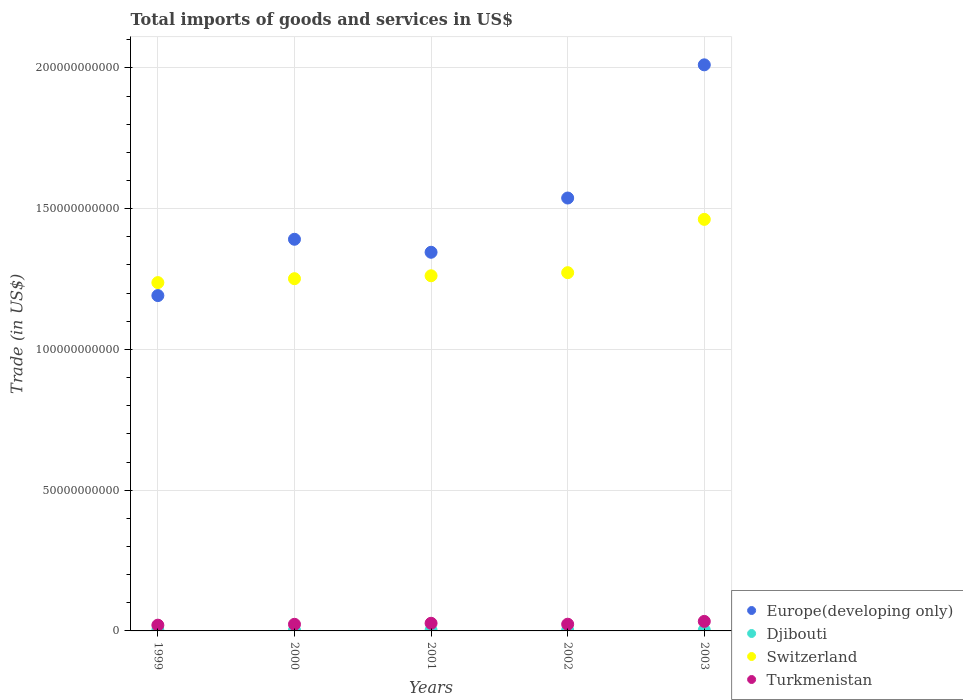How many different coloured dotlines are there?
Keep it short and to the point. 4. Is the number of dotlines equal to the number of legend labels?
Your response must be concise. Yes. What is the total imports of goods and services in Europe(developing only) in 2003?
Ensure brevity in your answer.  2.01e+11. Across all years, what is the maximum total imports of goods and services in Europe(developing only)?
Keep it short and to the point. 2.01e+11. Across all years, what is the minimum total imports of goods and services in Djibouti?
Your answer should be very brief. 2.59e+08. In which year was the total imports of goods and services in Switzerland maximum?
Ensure brevity in your answer.  2003. What is the total total imports of goods and services in Switzerland in the graph?
Your answer should be very brief. 6.48e+11. What is the difference between the total imports of goods and services in Europe(developing only) in 2000 and that in 2001?
Make the answer very short. 4.62e+09. What is the difference between the total imports of goods and services in Djibouti in 2001 and the total imports of goods and services in Switzerland in 2000?
Provide a short and direct response. -1.25e+11. What is the average total imports of goods and services in Turkmenistan per year?
Offer a terse response. 2.58e+09. In the year 2001, what is the difference between the total imports of goods and services in Djibouti and total imports of goods and services in Switzerland?
Your response must be concise. -1.26e+11. What is the ratio of the total imports of goods and services in Switzerland in 2002 to that in 2003?
Your answer should be compact. 0.87. Is the difference between the total imports of goods and services in Djibouti in 1999 and 2002 greater than the difference between the total imports of goods and services in Switzerland in 1999 and 2002?
Give a very brief answer. Yes. What is the difference between the highest and the second highest total imports of goods and services in Djibouti?
Provide a succinct answer. 2.75e+07. What is the difference between the highest and the lowest total imports of goods and services in Switzerland?
Your response must be concise. 2.25e+1. Is the sum of the total imports of goods and services in Turkmenistan in 1999 and 2003 greater than the maximum total imports of goods and services in Europe(developing only) across all years?
Your answer should be compact. No. Is it the case that in every year, the sum of the total imports of goods and services in Djibouti and total imports of goods and services in Europe(developing only)  is greater than the total imports of goods and services in Switzerland?
Ensure brevity in your answer.  No. Does the total imports of goods and services in Europe(developing only) monotonically increase over the years?
Offer a very short reply. No. Is the total imports of goods and services in Europe(developing only) strictly less than the total imports of goods and services in Turkmenistan over the years?
Your answer should be compact. No. How are the legend labels stacked?
Provide a succinct answer. Vertical. What is the title of the graph?
Offer a very short reply. Total imports of goods and services in US$. Does "Monaco" appear as one of the legend labels in the graph?
Offer a terse response. No. What is the label or title of the Y-axis?
Your answer should be very brief. Trade (in US$). What is the Trade (in US$) of Europe(developing only) in 1999?
Keep it short and to the point. 1.19e+11. What is the Trade (in US$) of Djibouti in 1999?
Provide a short and direct response. 2.59e+08. What is the Trade (in US$) of Switzerland in 1999?
Offer a very short reply. 1.24e+11. What is the Trade (in US$) in Turkmenistan in 1999?
Your response must be concise. 2.05e+09. What is the Trade (in US$) in Europe(developing only) in 2000?
Offer a very short reply. 1.39e+11. What is the Trade (in US$) in Djibouti in 2000?
Make the answer very short. 2.78e+08. What is the Trade (in US$) in Switzerland in 2000?
Offer a very short reply. 1.25e+11. What is the Trade (in US$) of Turkmenistan in 2000?
Give a very brief answer. 2.35e+09. What is the Trade (in US$) in Europe(developing only) in 2001?
Your response must be concise. 1.35e+11. What is the Trade (in US$) of Djibouti in 2001?
Offer a terse response. 2.62e+08. What is the Trade (in US$) of Switzerland in 2001?
Your answer should be compact. 1.26e+11. What is the Trade (in US$) in Turkmenistan in 2001?
Give a very brief answer. 2.72e+09. What is the Trade (in US$) of Europe(developing only) in 2002?
Make the answer very short. 1.54e+11. What is the Trade (in US$) of Djibouti in 2002?
Keep it short and to the point. 2.59e+08. What is the Trade (in US$) in Switzerland in 2002?
Your answer should be very brief. 1.27e+11. What is the Trade (in US$) in Turkmenistan in 2002?
Your answer should be compact. 2.38e+09. What is the Trade (in US$) of Europe(developing only) in 2003?
Offer a terse response. 2.01e+11. What is the Trade (in US$) in Djibouti in 2003?
Offer a very short reply. 3.05e+08. What is the Trade (in US$) in Switzerland in 2003?
Your response must be concise. 1.46e+11. What is the Trade (in US$) of Turkmenistan in 2003?
Provide a succinct answer. 3.38e+09. Across all years, what is the maximum Trade (in US$) in Europe(developing only)?
Make the answer very short. 2.01e+11. Across all years, what is the maximum Trade (in US$) in Djibouti?
Keep it short and to the point. 3.05e+08. Across all years, what is the maximum Trade (in US$) in Switzerland?
Provide a short and direct response. 1.46e+11. Across all years, what is the maximum Trade (in US$) of Turkmenistan?
Your answer should be compact. 3.38e+09. Across all years, what is the minimum Trade (in US$) in Europe(developing only)?
Ensure brevity in your answer.  1.19e+11. Across all years, what is the minimum Trade (in US$) of Djibouti?
Ensure brevity in your answer.  2.59e+08. Across all years, what is the minimum Trade (in US$) in Switzerland?
Ensure brevity in your answer.  1.24e+11. Across all years, what is the minimum Trade (in US$) of Turkmenistan?
Keep it short and to the point. 2.05e+09. What is the total Trade (in US$) of Europe(developing only) in the graph?
Offer a terse response. 7.48e+11. What is the total Trade (in US$) of Djibouti in the graph?
Your answer should be compact. 1.36e+09. What is the total Trade (in US$) of Switzerland in the graph?
Provide a succinct answer. 6.48e+11. What is the total Trade (in US$) in Turkmenistan in the graph?
Your answer should be very brief. 1.29e+1. What is the difference between the Trade (in US$) of Europe(developing only) in 1999 and that in 2000?
Offer a terse response. -2.00e+1. What is the difference between the Trade (in US$) of Djibouti in 1999 and that in 2000?
Make the answer very short. -1.85e+07. What is the difference between the Trade (in US$) in Switzerland in 1999 and that in 2000?
Provide a succinct answer. -1.39e+09. What is the difference between the Trade (in US$) of Turkmenistan in 1999 and that in 2000?
Your response must be concise. -3.05e+08. What is the difference between the Trade (in US$) in Europe(developing only) in 1999 and that in 2001?
Your answer should be very brief. -1.54e+1. What is the difference between the Trade (in US$) of Djibouti in 1999 and that in 2001?
Offer a very short reply. -2.78e+06. What is the difference between the Trade (in US$) of Switzerland in 1999 and that in 2001?
Provide a short and direct response. -2.43e+09. What is the difference between the Trade (in US$) in Turkmenistan in 1999 and that in 2001?
Your response must be concise. -6.71e+08. What is the difference between the Trade (in US$) of Europe(developing only) in 1999 and that in 2002?
Ensure brevity in your answer.  -3.47e+1. What is the difference between the Trade (in US$) of Djibouti in 1999 and that in 2002?
Provide a succinct answer. 6.13e+05. What is the difference between the Trade (in US$) of Switzerland in 1999 and that in 2002?
Offer a very short reply. -3.53e+09. What is the difference between the Trade (in US$) in Turkmenistan in 1999 and that in 2002?
Make the answer very short. -3.37e+08. What is the difference between the Trade (in US$) in Europe(developing only) in 1999 and that in 2003?
Provide a short and direct response. -8.20e+1. What is the difference between the Trade (in US$) in Djibouti in 1999 and that in 2003?
Provide a short and direct response. -4.60e+07. What is the difference between the Trade (in US$) of Switzerland in 1999 and that in 2003?
Offer a very short reply. -2.25e+1. What is the difference between the Trade (in US$) in Turkmenistan in 1999 and that in 2003?
Give a very brief answer. -1.34e+09. What is the difference between the Trade (in US$) in Europe(developing only) in 2000 and that in 2001?
Provide a succinct answer. 4.62e+09. What is the difference between the Trade (in US$) of Djibouti in 2000 and that in 2001?
Provide a short and direct response. 1.57e+07. What is the difference between the Trade (in US$) of Switzerland in 2000 and that in 2001?
Ensure brevity in your answer.  -1.04e+09. What is the difference between the Trade (in US$) in Turkmenistan in 2000 and that in 2001?
Provide a succinct answer. -3.66e+08. What is the difference between the Trade (in US$) in Europe(developing only) in 2000 and that in 2002?
Keep it short and to the point. -1.47e+1. What is the difference between the Trade (in US$) in Djibouti in 2000 and that in 2002?
Your response must be concise. 1.91e+07. What is the difference between the Trade (in US$) of Switzerland in 2000 and that in 2002?
Keep it short and to the point. -2.14e+09. What is the difference between the Trade (in US$) in Turkmenistan in 2000 and that in 2002?
Make the answer very short. -3.20e+07. What is the difference between the Trade (in US$) of Europe(developing only) in 2000 and that in 2003?
Make the answer very short. -6.20e+1. What is the difference between the Trade (in US$) in Djibouti in 2000 and that in 2003?
Offer a very short reply. -2.75e+07. What is the difference between the Trade (in US$) in Switzerland in 2000 and that in 2003?
Give a very brief answer. -2.11e+1. What is the difference between the Trade (in US$) in Turkmenistan in 2000 and that in 2003?
Give a very brief answer. -1.03e+09. What is the difference between the Trade (in US$) of Europe(developing only) in 2001 and that in 2002?
Give a very brief answer. -1.93e+1. What is the difference between the Trade (in US$) of Djibouti in 2001 and that in 2002?
Give a very brief answer. 3.39e+06. What is the difference between the Trade (in US$) in Switzerland in 2001 and that in 2002?
Make the answer very short. -1.10e+09. What is the difference between the Trade (in US$) of Turkmenistan in 2001 and that in 2002?
Provide a succinct answer. 3.34e+08. What is the difference between the Trade (in US$) in Europe(developing only) in 2001 and that in 2003?
Your answer should be very brief. -6.66e+1. What is the difference between the Trade (in US$) of Djibouti in 2001 and that in 2003?
Your answer should be very brief. -4.32e+07. What is the difference between the Trade (in US$) in Switzerland in 2001 and that in 2003?
Your answer should be very brief. -2.00e+1. What is the difference between the Trade (in US$) in Turkmenistan in 2001 and that in 2003?
Offer a very short reply. -6.67e+08. What is the difference between the Trade (in US$) of Europe(developing only) in 2002 and that in 2003?
Provide a short and direct response. -4.73e+1. What is the difference between the Trade (in US$) in Djibouti in 2002 and that in 2003?
Give a very brief answer. -4.66e+07. What is the difference between the Trade (in US$) in Switzerland in 2002 and that in 2003?
Make the answer very short. -1.89e+1. What is the difference between the Trade (in US$) of Turkmenistan in 2002 and that in 2003?
Your response must be concise. -1.00e+09. What is the difference between the Trade (in US$) in Europe(developing only) in 1999 and the Trade (in US$) in Djibouti in 2000?
Your response must be concise. 1.19e+11. What is the difference between the Trade (in US$) of Europe(developing only) in 1999 and the Trade (in US$) of Switzerland in 2000?
Offer a terse response. -6.00e+09. What is the difference between the Trade (in US$) in Europe(developing only) in 1999 and the Trade (in US$) in Turkmenistan in 2000?
Offer a terse response. 1.17e+11. What is the difference between the Trade (in US$) in Djibouti in 1999 and the Trade (in US$) in Switzerland in 2000?
Ensure brevity in your answer.  -1.25e+11. What is the difference between the Trade (in US$) in Djibouti in 1999 and the Trade (in US$) in Turkmenistan in 2000?
Provide a succinct answer. -2.09e+09. What is the difference between the Trade (in US$) in Switzerland in 1999 and the Trade (in US$) in Turkmenistan in 2000?
Keep it short and to the point. 1.21e+11. What is the difference between the Trade (in US$) of Europe(developing only) in 1999 and the Trade (in US$) of Djibouti in 2001?
Make the answer very short. 1.19e+11. What is the difference between the Trade (in US$) of Europe(developing only) in 1999 and the Trade (in US$) of Switzerland in 2001?
Offer a very short reply. -7.04e+09. What is the difference between the Trade (in US$) in Europe(developing only) in 1999 and the Trade (in US$) in Turkmenistan in 2001?
Provide a succinct answer. 1.16e+11. What is the difference between the Trade (in US$) in Djibouti in 1999 and the Trade (in US$) in Switzerland in 2001?
Keep it short and to the point. -1.26e+11. What is the difference between the Trade (in US$) of Djibouti in 1999 and the Trade (in US$) of Turkmenistan in 2001?
Your answer should be compact. -2.46e+09. What is the difference between the Trade (in US$) of Switzerland in 1999 and the Trade (in US$) of Turkmenistan in 2001?
Ensure brevity in your answer.  1.21e+11. What is the difference between the Trade (in US$) of Europe(developing only) in 1999 and the Trade (in US$) of Djibouti in 2002?
Ensure brevity in your answer.  1.19e+11. What is the difference between the Trade (in US$) of Europe(developing only) in 1999 and the Trade (in US$) of Switzerland in 2002?
Give a very brief answer. -8.14e+09. What is the difference between the Trade (in US$) of Europe(developing only) in 1999 and the Trade (in US$) of Turkmenistan in 2002?
Offer a terse response. 1.17e+11. What is the difference between the Trade (in US$) in Djibouti in 1999 and the Trade (in US$) in Switzerland in 2002?
Ensure brevity in your answer.  -1.27e+11. What is the difference between the Trade (in US$) of Djibouti in 1999 and the Trade (in US$) of Turkmenistan in 2002?
Your answer should be very brief. -2.12e+09. What is the difference between the Trade (in US$) in Switzerland in 1999 and the Trade (in US$) in Turkmenistan in 2002?
Give a very brief answer. 1.21e+11. What is the difference between the Trade (in US$) of Europe(developing only) in 1999 and the Trade (in US$) of Djibouti in 2003?
Your response must be concise. 1.19e+11. What is the difference between the Trade (in US$) in Europe(developing only) in 1999 and the Trade (in US$) in Switzerland in 2003?
Offer a terse response. -2.71e+1. What is the difference between the Trade (in US$) in Europe(developing only) in 1999 and the Trade (in US$) in Turkmenistan in 2003?
Your answer should be very brief. 1.16e+11. What is the difference between the Trade (in US$) in Djibouti in 1999 and the Trade (in US$) in Switzerland in 2003?
Offer a very short reply. -1.46e+11. What is the difference between the Trade (in US$) in Djibouti in 1999 and the Trade (in US$) in Turkmenistan in 2003?
Offer a terse response. -3.12e+09. What is the difference between the Trade (in US$) of Switzerland in 1999 and the Trade (in US$) of Turkmenistan in 2003?
Offer a very short reply. 1.20e+11. What is the difference between the Trade (in US$) of Europe(developing only) in 2000 and the Trade (in US$) of Djibouti in 2001?
Make the answer very short. 1.39e+11. What is the difference between the Trade (in US$) in Europe(developing only) in 2000 and the Trade (in US$) in Switzerland in 2001?
Your answer should be compact. 1.30e+1. What is the difference between the Trade (in US$) in Europe(developing only) in 2000 and the Trade (in US$) in Turkmenistan in 2001?
Your answer should be compact. 1.36e+11. What is the difference between the Trade (in US$) of Djibouti in 2000 and the Trade (in US$) of Switzerland in 2001?
Your response must be concise. -1.26e+11. What is the difference between the Trade (in US$) of Djibouti in 2000 and the Trade (in US$) of Turkmenistan in 2001?
Provide a short and direct response. -2.44e+09. What is the difference between the Trade (in US$) in Switzerland in 2000 and the Trade (in US$) in Turkmenistan in 2001?
Make the answer very short. 1.22e+11. What is the difference between the Trade (in US$) in Europe(developing only) in 2000 and the Trade (in US$) in Djibouti in 2002?
Your response must be concise. 1.39e+11. What is the difference between the Trade (in US$) in Europe(developing only) in 2000 and the Trade (in US$) in Switzerland in 2002?
Your response must be concise. 1.19e+1. What is the difference between the Trade (in US$) of Europe(developing only) in 2000 and the Trade (in US$) of Turkmenistan in 2002?
Provide a succinct answer. 1.37e+11. What is the difference between the Trade (in US$) of Djibouti in 2000 and the Trade (in US$) of Switzerland in 2002?
Your answer should be very brief. -1.27e+11. What is the difference between the Trade (in US$) in Djibouti in 2000 and the Trade (in US$) in Turkmenistan in 2002?
Your answer should be compact. -2.11e+09. What is the difference between the Trade (in US$) in Switzerland in 2000 and the Trade (in US$) in Turkmenistan in 2002?
Keep it short and to the point. 1.23e+11. What is the difference between the Trade (in US$) in Europe(developing only) in 2000 and the Trade (in US$) in Djibouti in 2003?
Your answer should be compact. 1.39e+11. What is the difference between the Trade (in US$) of Europe(developing only) in 2000 and the Trade (in US$) of Switzerland in 2003?
Offer a very short reply. -7.07e+09. What is the difference between the Trade (in US$) of Europe(developing only) in 2000 and the Trade (in US$) of Turkmenistan in 2003?
Give a very brief answer. 1.36e+11. What is the difference between the Trade (in US$) in Djibouti in 2000 and the Trade (in US$) in Switzerland in 2003?
Offer a terse response. -1.46e+11. What is the difference between the Trade (in US$) in Djibouti in 2000 and the Trade (in US$) in Turkmenistan in 2003?
Your answer should be compact. -3.11e+09. What is the difference between the Trade (in US$) in Switzerland in 2000 and the Trade (in US$) in Turkmenistan in 2003?
Your answer should be compact. 1.22e+11. What is the difference between the Trade (in US$) of Europe(developing only) in 2001 and the Trade (in US$) of Djibouti in 2002?
Provide a succinct answer. 1.34e+11. What is the difference between the Trade (in US$) of Europe(developing only) in 2001 and the Trade (in US$) of Switzerland in 2002?
Give a very brief answer. 7.25e+09. What is the difference between the Trade (in US$) in Europe(developing only) in 2001 and the Trade (in US$) in Turkmenistan in 2002?
Your response must be concise. 1.32e+11. What is the difference between the Trade (in US$) in Djibouti in 2001 and the Trade (in US$) in Switzerland in 2002?
Ensure brevity in your answer.  -1.27e+11. What is the difference between the Trade (in US$) in Djibouti in 2001 and the Trade (in US$) in Turkmenistan in 2002?
Your answer should be very brief. -2.12e+09. What is the difference between the Trade (in US$) in Switzerland in 2001 and the Trade (in US$) in Turkmenistan in 2002?
Make the answer very short. 1.24e+11. What is the difference between the Trade (in US$) of Europe(developing only) in 2001 and the Trade (in US$) of Djibouti in 2003?
Your response must be concise. 1.34e+11. What is the difference between the Trade (in US$) in Europe(developing only) in 2001 and the Trade (in US$) in Switzerland in 2003?
Your response must be concise. -1.17e+1. What is the difference between the Trade (in US$) of Europe(developing only) in 2001 and the Trade (in US$) of Turkmenistan in 2003?
Give a very brief answer. 1.31e+11. What is the difference between the Trade (in US$) of Djibouti in 2001 and the Trade (in US$) of Switzerland in 2003?
Provide a short and direct response. -1.46e+11. What is the difference between the Trade (in US$) of Djibouti in 2001 and the Trade (in US$) of Turkmenistan in 2003?
Ensure brevity in your answer.  -3.12e+09. What is the difference between the Trade (in US$) of Switzerland in 2001 and the Trade (in US$) of Turkmenistan in 2003?
Provide a succinct answer. 1.23e+11. What is the difference between the Trade (in US$) of Europe(developing only) in 2002 and the Trade (in US$) of Djibouti in 2003?
Your answer should be very brief. 1.53e+11. What is the difference between the Trade (in US$) of Europe(developing only) in 2002 and the Trade (in US$) of Switzerland in 2003?
Ensure brevity in your answer.  7.58e+09. What is the difference between the Trade (in US$) in Europe(developing only) in 2002 and the Trade (in US$) in Turkmenistan in 2003?
Ensure brevity in your answer.  1.50e+11. What is the difference between the Trade (in US$) of Djibouti in 2002 and the Trade (in US$) of Switzerland in 2003?
Offer a terse response. -1.46e+11. What is the difference between the Trade (in US$) in Djibouti in 2002 and the Trade (in US$) in Turkmenistan in 2003?
Your answer should be very brief. -3.13e+09. What is the difference between the Trade (in US$) of Switzerland in 2002 and the Trade (in US$) of Turkmenistan in 2003?
Ensure brevity in your answer.  1.24e+11. What is the average Trade (in US$) in Europe(developing only) per year?
Your answer should be compact. 1.50e+11. What is the average Trade (in US$) of Djibouti per year?
Your response must be concise. 2.73e+08. What is the average Trade (in US$) of Switzerland per year?
Keep it short and to the point. 1.30e+11. What is the average Trade (in US$) of Turkmenistan per year?
Ensure brevity in your answer.  2.58e+09. In the year 1999, what is the difference between the Trade (in US$) of Europe(developing only) and Trade (in US$) of Djibouti?
Keep it short and to the point. 1.19e+11. In the year 1999, what is the difference between the Trade (in US$) of Europe(developing only) and Trade (in US$) of Switzerland?
Keep it short and to the point. -4.61e+09. In the year 1999, what is the difference between the Trade (in US$) in Europe(developing only) and Trade (in US$) in Turkmenistan?
Ensure brevity in your answer.  1.17e+11. In the year 1999, what is the difference between the Trade (in US$) in Djibouti and Trade (in US$) in Switzerland?
Your answer should be compact. -1.23e+11. In the year 1999, what is the difference between the Trade (in US$) of Djibouti and Trade (in US$) of Turkmenistan?
Your answer should be very brief. -1.79e+09. In the year 1999, what is the difference between the Trade (in US$) of Switzerland and Trade (in US$) of Turkmenistan?
Ensure brevity in your answer.  1.22e+11. In the year 2000, what is the difference between the Trade (in US$) of Europe(developing only) and Trade (in US$) of Djibouti?
Your response must be concise. 1.39e+11. In the year 2000, what is the difference between the Trade (in US$) of Europe(developing only) and Trade (in US$) of Switzerland?
Keep it short and to the point. 1.40e+1. In the year 2000, what is the difference between the Trade (in US$) of Europe(developing only) and Trade (in US$) of Turkmenistan?
Provide a short and direct response. 1.37e+11. In the year 2000, what is the difference between the Trade (in US$) in Djibouti and Trade (in US$) in Switzerland?
Your answer should be compact. -1.25e+11. In the year 2000, what is the difference between the Trade (in US$) of Djibouti and Trade (in US$) of Turkmenistan?
Give a very brief answer. -2.07e+09. In the year 2000, what is the difference between the Trade (in US$) in Switzerland and Trade (in US$) in Turkmenistan?
Provide a succinct answer. 1.23e+11. In the year 2001, what is the difference between the Trade (in US$) of Europe(developing only) and Trade (in US$) of Djibouti?
Provide a succinct answer. 1.34e+11. In the year 2001, what is the difference between the Trade (in US$) in Europe(developing only) and Trade (in US$) in Switzerland?
Your answer should be very brief. 8.35e+09. In the year 2001, what is the difference between the Trade (in US$) of Europe(developing only) and Trade (in US$) of Turkmenistan?
Offer a very short reply. 1.32e+11. In the year 2001, what is the difference between the Trade (in US$) in Djibouti and Trade (in US$) in Switzerland?
Provide a succinct answer. -1.26e+11. In the year 2001, what is the difference between the Trade (in US$) in Djibouti and Trade (in US$) in Turkmenistan?
Your response must be concise. -2.45e+09. In the year 2001, what is the difference between the Trade (in US$) of Switzerland and Trade (in US$) of Turkmenistan?
Offer a very short reply. 1.23e+11. In the year 2002, what is the difference between the Trade (in US$) in Europe(developing only) and Trade (in US$) in Djibouti?
Your answer should be compact. 1.54e+11. In the year 2002, what is the difference between the Trade (in US$) in Europe(developing only) and Trade (in US$) in Switzerland?
Your answer should be compact. 2.65e+1. In the year 2002, what is the difference between the Trade (in US$) of Europe(developing only) and Trade (in US$) of Turkmenistan?
Offer a terse response. 1.51e+11. In the year 2002, what is the difference between the Trade (in US$) of Djibouti and Trade (in US$) of Switzerland?
Keep it short and to the point. -1.27e+11. In the year 2002, what is the difference between the Trade (in US$) in Djibouti and Trade (in US$) in Turkmenistan?
Your response must be concise. -2.12e+09. In the year 2002, what is the difference between the Trade (in US$) in Switzerland and Trade (in US$) in Turkmenistan?
Provide a short and direct response. 1.25e+11. In the year 2003, what is the difference between the Trade (in US$) in Europe(developing only) and Trade (in US$) in Djibouti?
Your response must be concise. 2.01e+11. In the year 2003, what is the difference between the Trade (in US$) of Europe(developing only) and Trade (in US$) of Switzerland?
Offer a terse response. 5.49e+1. In the year 2003, what is the difference between the Trade (in US$) of Europe(developing only) and Trade (in US$) of Turkmenistan?
Your answer should be very brief. 1.98e+11. In the year 2003, what is the difference between the Trade (in US$) in Djibouti and Trade (in US$) in Switzerland?
Make the answer very short. -1.46e+11. In the year 2003, what is the difference between the Trade (in US$) of Djibouti and Trade (in US$) of Turkmenistan?
Provide a succinct answer. -3.08e+09. In the year 2003, what is the difference between the Trade (in US$) of Switzerland and Trade (in US$) of Turkmenistan?
Your response must be concise. 1.43e+11. What is the ratio of the Trade (in US$) in Europe(developing only) in 1999 to that in 2000?
Give a very brief answer. 0.86. What is the ratio of the Trade (in US$) in Djibouti in 1999 to that in 2000?
Provide a short and direct response. 0.93. What is the ratio of the Trade (in US$) of Switzerland in 1999 to that in 2000?
Your answer should be very brief. 0.99. What is the ratio of the Trade (in US$) in Turkmenistan in 1999 to that in 2000?
Provide a short and direct response. 0.87. What is the ratio of the Trade (in US$) of Europe(developing only) in 1999 to that in 2001?
Offer a very short reply. 0.89. What is the ratio of the Trade (in US$) in Switzerland in 1999 to that in 2001?
Offer a terse response. 0.98. What is the ratio of the Trade (in US$) of Turkmenistan in 1999 to that in 2001?
Ensure brevity in your answer.  0.75. What is the ratio of the Trade (in US$) in Europe(developing only) in 1999 to that in 2002?
Offer a terse response. 0.77. What is the ratio of the Trade (in US$) of Switzerland in 1999 to that in 2002?
Offer a terse response. 0.97. What is the ratio of the Trade (in US$) of Turkmenistan in 1999 to that in 2002?
Your answer should be compact. 0.86. What is the ratio of the Trade (in US$) in Europe(developing only) in 1999 to that in 2003?
Provide a short and direct response. 0.59. What is the ratio of the Trade (in US$) of Djibouti in 1999 to that in 2003?
Make the answer very short. 0.85. What is the ratio of the Trade (in US$) of Switzerland in 1999 to that in 2003?
Keep it short and to the point. 0.85. What is the ratio of the Trade (in US$) in Turkmenistan in 1999 to that in 2003?
Make the answer very short. 0.6. What is the ratio of the Trade (in US$) in Europe(developing only) in 2000 to that in 2001?
Your response must be concise. 1.03. What is the ratio of the Trade (in US$) of Djibouti in 2000 to that in 2001?
Keep it short and to the point. 1.06. What is the ratio of the Trade (in US$) of Turkmenistan in 2000 to that in 2001?
Ensure brevity in your answer.  0.87. What is the ratio of the Trade (in US$) in Europe(developing only) in 2000 to that in 2002?
Make the answer very short. 0.9. What is the ratio of the Trade (in US$) in Djibouti in 2000 to that in 2002?
Your response must be concise. 1.07. What is the ratio of the Trade (in US$) in Switzerland in 2000 to that in 2002?
Give a very brief answer. 0.98. What is the ratio of the Trade (in US$) of Turkmenistan in 2000 to that in 2002?
Give a very brief answer. 0.99. What is the ratio of the Trade (in US$) of Europe(developing only) in 2000 to that in 2003?
Offer a very short reply. 0.69. What is the ratio of the Trade (in US$) of Djibouti in 2000 to that in 2003?
Provide a succinct answer. 0.91. What is the ratio of the Trade (in US$) in Switzerland in 2000 to that in 2003?
Your answer should be very brief. 0.86. What is the ratio of the Trade (in US$) of Turkmenistan in 2000 to that in 2003?
Your answer should be very brief. 0.69. What is the ratio of the Trade (in US$) of Europe(developing only) in 2001 to that in 2002?
Give a very brief answer. 0.87. What is the ratio of the Trade (in US$) in Djibouti in 2001 to that in 2002?
Provide a succinct answer. 1.01. What is the ratio of the Trade (in US$) of Switzerland in 2001 to that in 2002?
Provide a succinct answer. 0.99. What is the ratio of the Trade (in US$) in Turkmenistan in 2001 to that in 2002?
Your answer should be compact. 1.14. What is the ratio of the Trade (in US$) of Europe(developing only) in 2001 to that in 2003?
Provide a short and direct response. 0.67. What is the ratio of the Trade (in US$) of Djibouti in 2001 to that in 2003?
Offer a very short reply. 0.86. What is the ratio of the Trade (in US$) of Switzerland in 2001 to that in 2003?
Offer a terse response. 0.86. What is the ratio of the Trade (in US$) of Turkmenistan in 2001 to that in 2003?
Offer a very short reply. 0.8. What is the ratio of the Trade (in US$) in Europe(developing only) in 2002 to that in 2003?
Offer a terse response. 0.76. What is the ratio of the Trade (in US$) in Djibouti in 2002 to that in 2003?
Make the answer very short. 0.85. What is the ratio of the Trade (in US$) in Switzerland in 2002 to that in 2003?
Provide a short and direct response. 0.87. What is the ratio of the Trade (in US$) of Turkmenistan in 2002 to that in 2003?
Offer a very short reply. 0.7. What is the difference between the highest and the second highest Trade (in US$) in Europe(developing only)?
Give a very brief answer. 4.73e+1. What is the difference between the highest and the second highest Trade (in US$) in Djibouti?
Your response must be concise. 2.75e+07. What is the difference between the highest and the second highest Trade (in US$) in Switzerland?
Ensure brevity in your answer.  1.89e+1. What is the difference between the highest and the second highest Trade (in US$) in Turkmenistan?
Your answer should be compact. 6.67e+08. What is the difference between the highest and the lowest Trade (in US$) of Europe(developing only)?
Provide a succinct answer. 8.20e+1. What is the difference between the highest and the lowest Trade (in US$) in Djibouti?
Keep it short and to the point. 4.66e+07. What is the difference between the highest and the lowest Trade (in US$) of Switzerland?
Offer a terse response. 2.25e+1. What is the difference between the highest and the lowest Trade (in US$) of Turkmenistan?
Make the answer very short. 1.34e+09. 